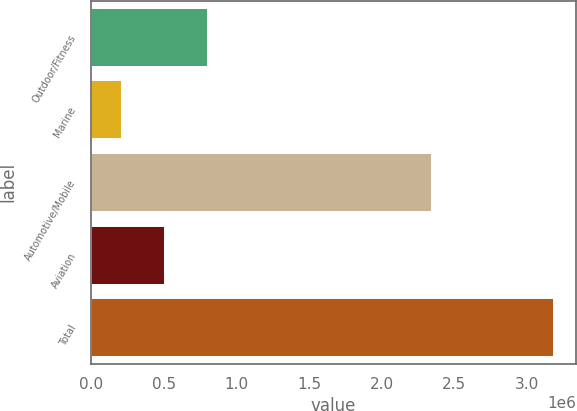Convert chart to OTSL. <chart><loc_0><loc_0><loc_500><loc_500><bar_chart><fcel>Outdoor/Fitness<fcel>Marine<fcel>Automotive/Mobile<fcel>Aviation<fcel>Total<nl><fcel>798783<fcel>203399<fcel>2.34218e+06<fcel>501091<fcel>3.18032e+06<nl></chart> 